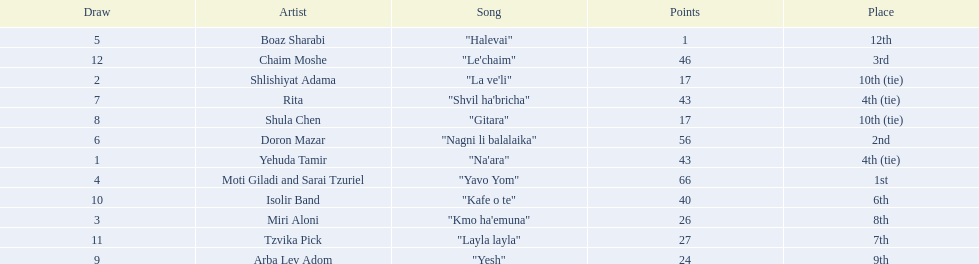What are the points? 43, 17, 26, 66, 1, 56, 43, 17, 24, 40, 27, 46. What is the least? 1. Which artist has that much Boaz Sharabi. 